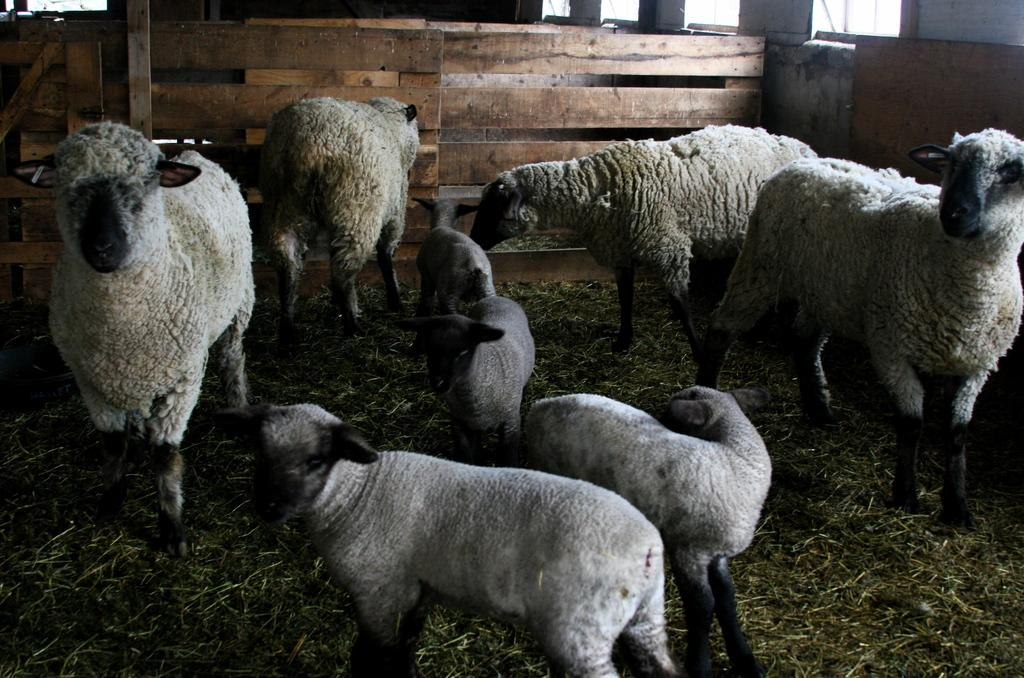What type of living organisms can be seen in the image? There are animals in the image. What colors are the animals in the image? The animals are in white and black color. What type of fencing is present in the image? There is wooden fencing in the image. What type of vegetation can be seen in the image? Dry grass is visible in the image. How many legs does the quilt have in the image? There is no quilt present in the image, so it is not possible to determine how many legs it might have. 